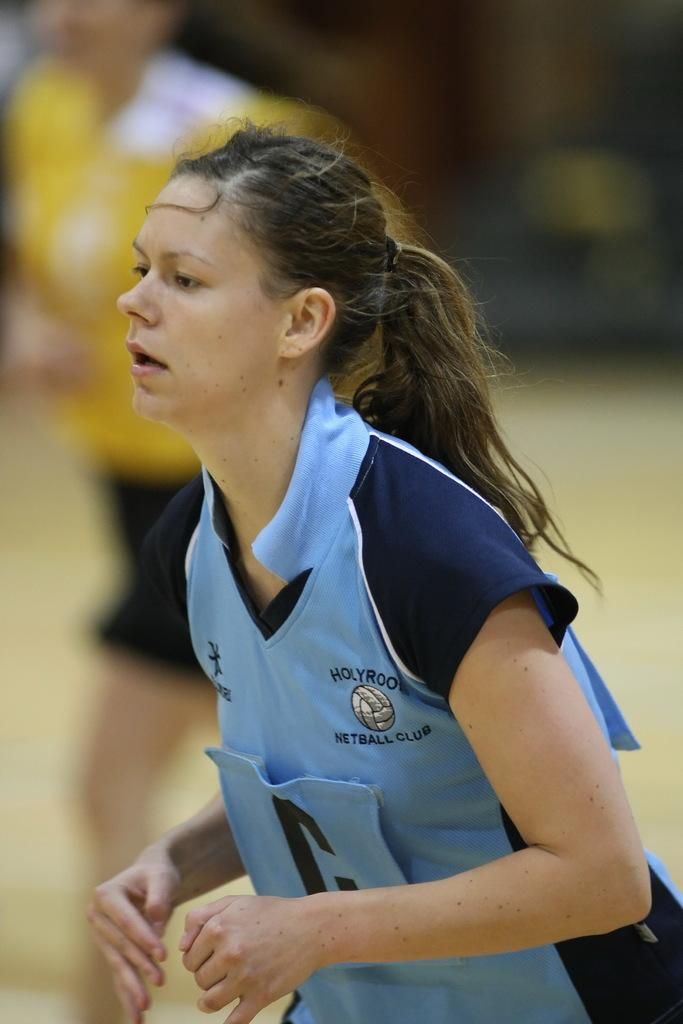<image>
Describe the image concisely. A player for the Hoybrook Netball Club waits for her turn. 